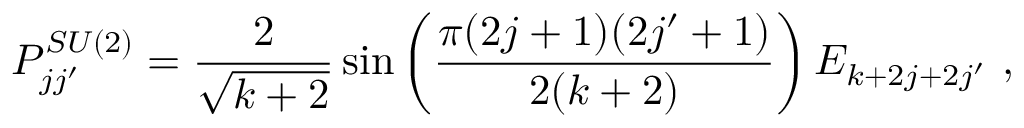Convert formula to latex. <formula><loc_0><loc_0><loc_500><loc_500>P _ { j j ^ { \prime } } ^ { S U ( 2 ) } = \frac { 2 } { \sqrt { k + 2 } } \sin \left ( \frac { \pi ( 2 j + 1 ) ( 2 j ^ { \prime } + 1 ) } { 2 ( k + 2 ) } \right ) E _ { k + 2 j + 2 j ^ { \prime } } ,</formula> 